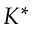Convert formula to latex. <formula><loc_0><loc_0><loc_500><loc_500>K ^ { * }</formula> 